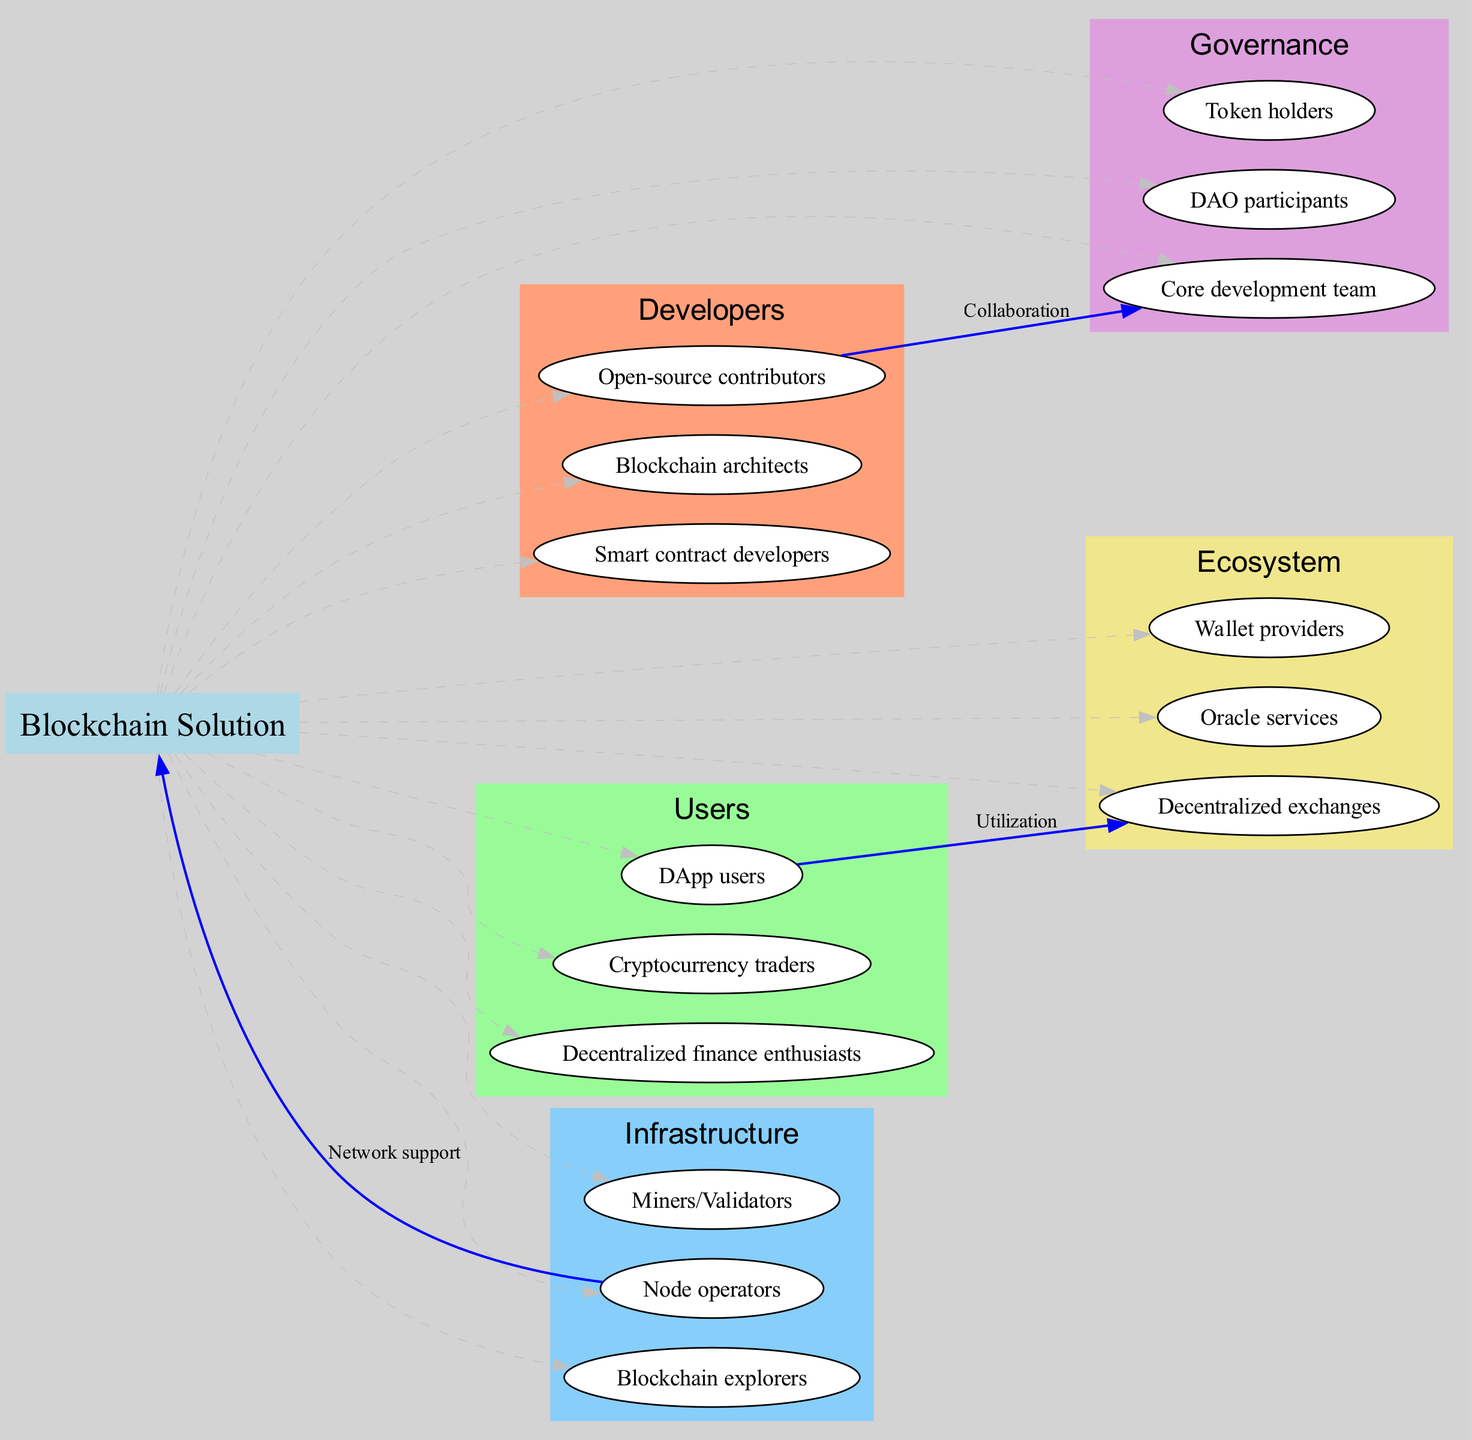What is the central node in the diagram? The central node is explicitly labeled as “Blockchain Solution” at the center of the diagram, indicating its primary focus.
Answer: Blockchain Solution How many stakeholder groups are there? Upon counting the distinct stakeholder groups presented in the diagram, there are a total of five groups outlined.
Answer: 5 Which group includes “Smart contract developers”? In the diagram, the “Smart contract developers” are listed under the stakeholder group “Developers,” which is one of the categorized sections.
Answer: Developers What connection type is between “Open-source contributors” and “Core development team”? The diagram clearly depicts the relationship as “Collaboration” between these two specific nodes, indicating their interaction type.
Answer: Collaboration What role do “Node operators” play in relation to the blockchain solution? “Node operators” are depicted to provide “Network support” to the Blockchain Solution, signifying their importance in the ecosystem.
Answer: Network support How many nodes are associated with the “Users” group? The “Users” group contains three specific nodes, which can be counted directly from that section of the diagram.
Answer: 3 What is the connection between “Decentralized exchanges” and “DApp users”? The diagram indicates that “DApp users” utilize “Decentralized exchanges,” establishing a functional relationship between these nodes.
Answer: Utilization Which party is labeled as contributing to “Blockchain explorers”? In the diagram, no direct connection is shown from other nodes to “Blockchain explorers,” suggesting it is a standalone role without inbound connections in this context.
Answer: None What is the edge connecting “Node operators” to the “Blockchain Solution” labeled? The edge from “Node operators” to the “Blockchain Solution” is labeled “Network support,” illustrating the support role this group plays.
Answer: Network support 